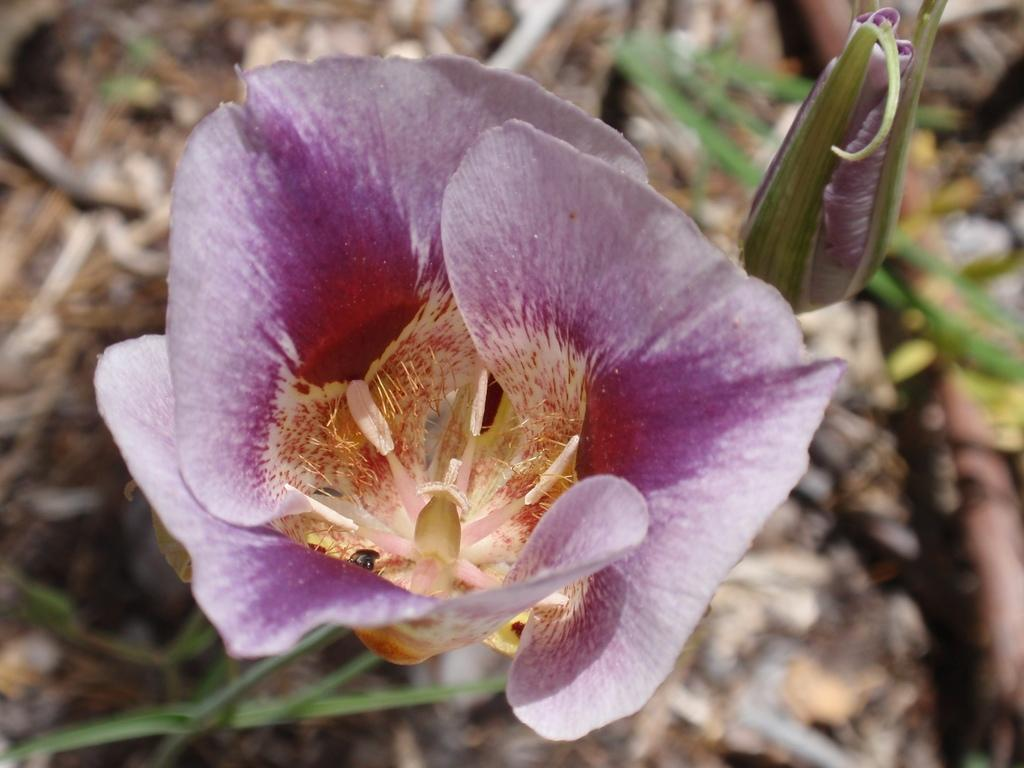What are the two flowers in the center of the image? There are two flowers in the center of the image, one is pink, and the other is yellow. What can be seen in the background of the image? In the background of the image, there is a plant, dry leaves, and a few other objects. How many flowers are in the image? There are two flowers in the image, both in the center. What colors are the flowers? The flowers are pink and yellow. What type of adjustment does the actor make in the image? There is no actor present in the image, so no adjustment can be observed. 